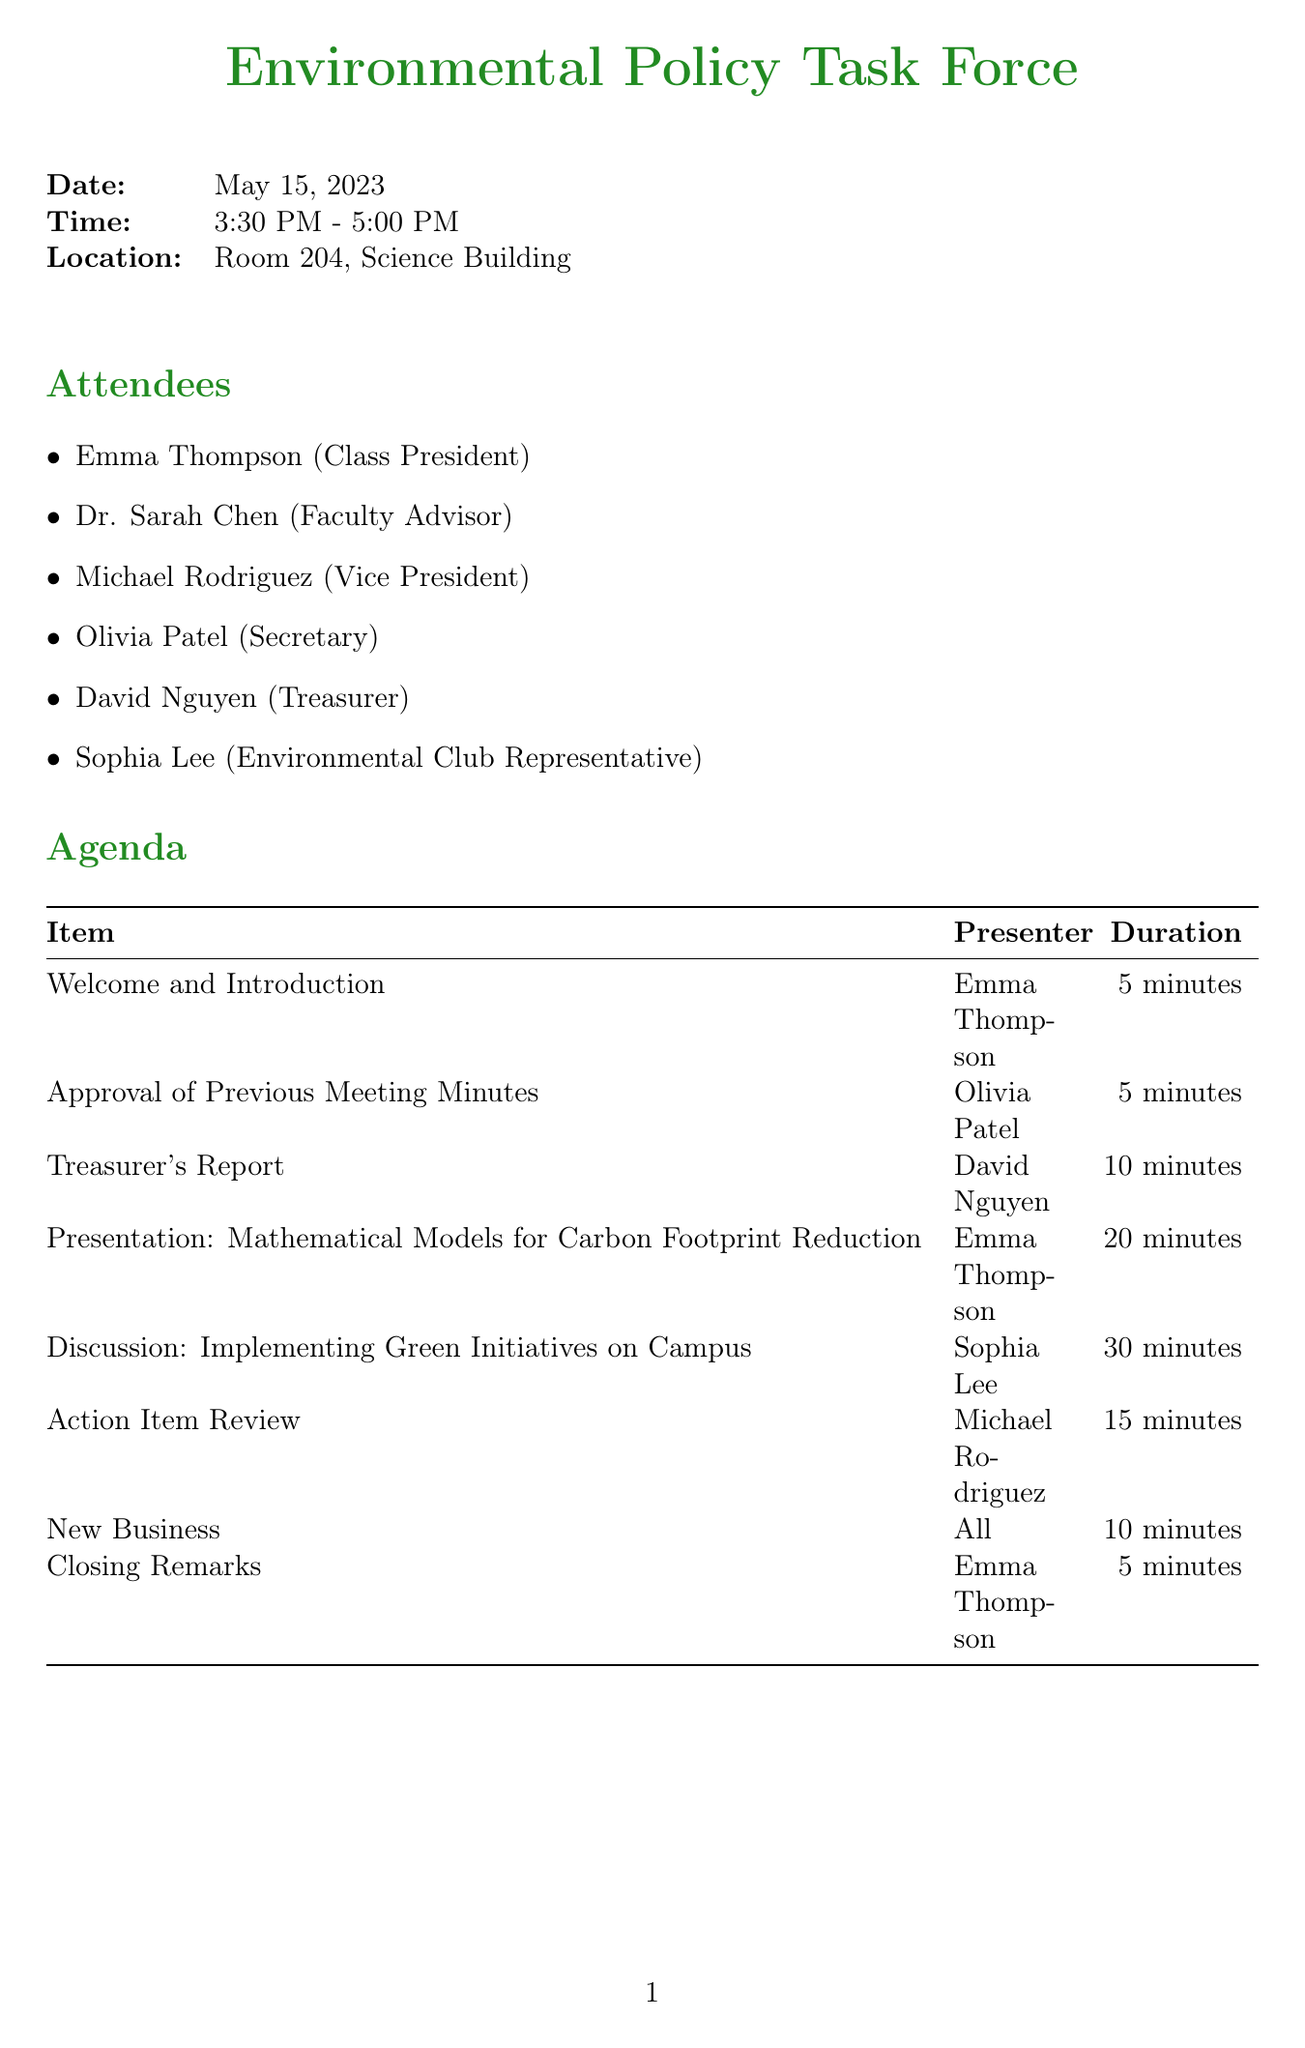What is the meeting title? The meeting title is specified in the document header and indicates the main focus of the meeting.
Answer: Environmental Policy Task Force Who presented the Treasurer's Report? The presenter of the Treasurer's Report is listed in the agenda section of the document.
Answer: David Nguyen What is the duration of the discussion on implementing green initiatives on campus? The duration is the amount of time allocated for that specific agenda item, which can be found in the agenda section.
Answer: 30 minutes What is the due date for creating a budget proposal for eco-friendly water bottle refill stations? The due date for this action item is provided in the action items section of the document.
Answer: May 22, 2023 Which item is scheduled for the next meeting? The next meeting provides information about what will be discussed next, indicated in the next meeting section.
Answer: Next Meeting: May 29, 2023 Who is responsible for liaising with local government officials? The assignee for this action item is listed in the action items section, specifying who is tasked with it.
Answer: Sophia Lee What is the status of the action item regarding the statistical analysis of energy consumption? The status provides insight into the progress made on this action item, which is mentioned in the action items section.
Answer: In Progress How long is the entire meeting scheduled to last? The total meeting duration can be determined by the start and end times specified in the meeting details.
Answer: 1 hour 30 minutes 